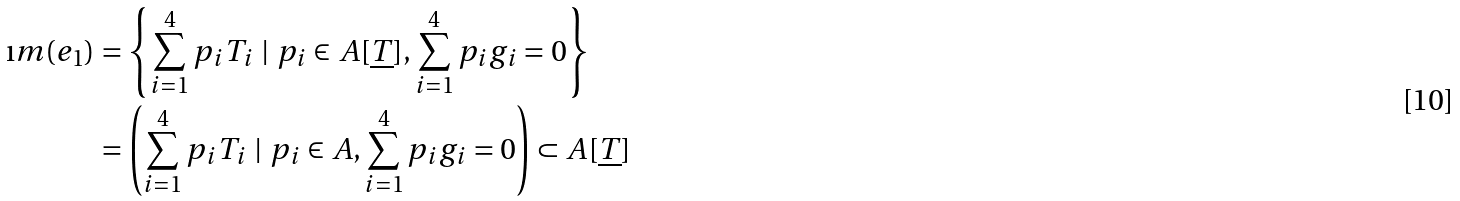<formula> <loc_0><loc_0><loc_500><loc_500>\i m ( e _ { 1 } ) & = \left \{ \sum _ { i = 1 } ^ { 4 } p _ { i } T _ { i } \ | \ p _ { i } \in A [ \underline { T } ] , \sum _ { i = 1 } ^ { 4 } p _ { i } g _ { i } = 0 \right \} \\ & = \left ( \sum _ { i = 1 } ^ { 4 } p _ { i } T _ { i } \ | \ p _ { i } \in A , \sum _ { i = 1 } ^ { 4 } p _ { i } g _ { i } = 0 \right ) \subset A [ \underline { T } ]</formula> 